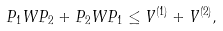Convert formula to latex. <formula><loc_0><loc_0><loc_500><loc_500>P _ { 1 } W P _ { 2 } + P _ { 2 } W P _ { 1 } \leq V ^ { ( 1 ) } + V ^ { ( 2 ) } ,</formula> 